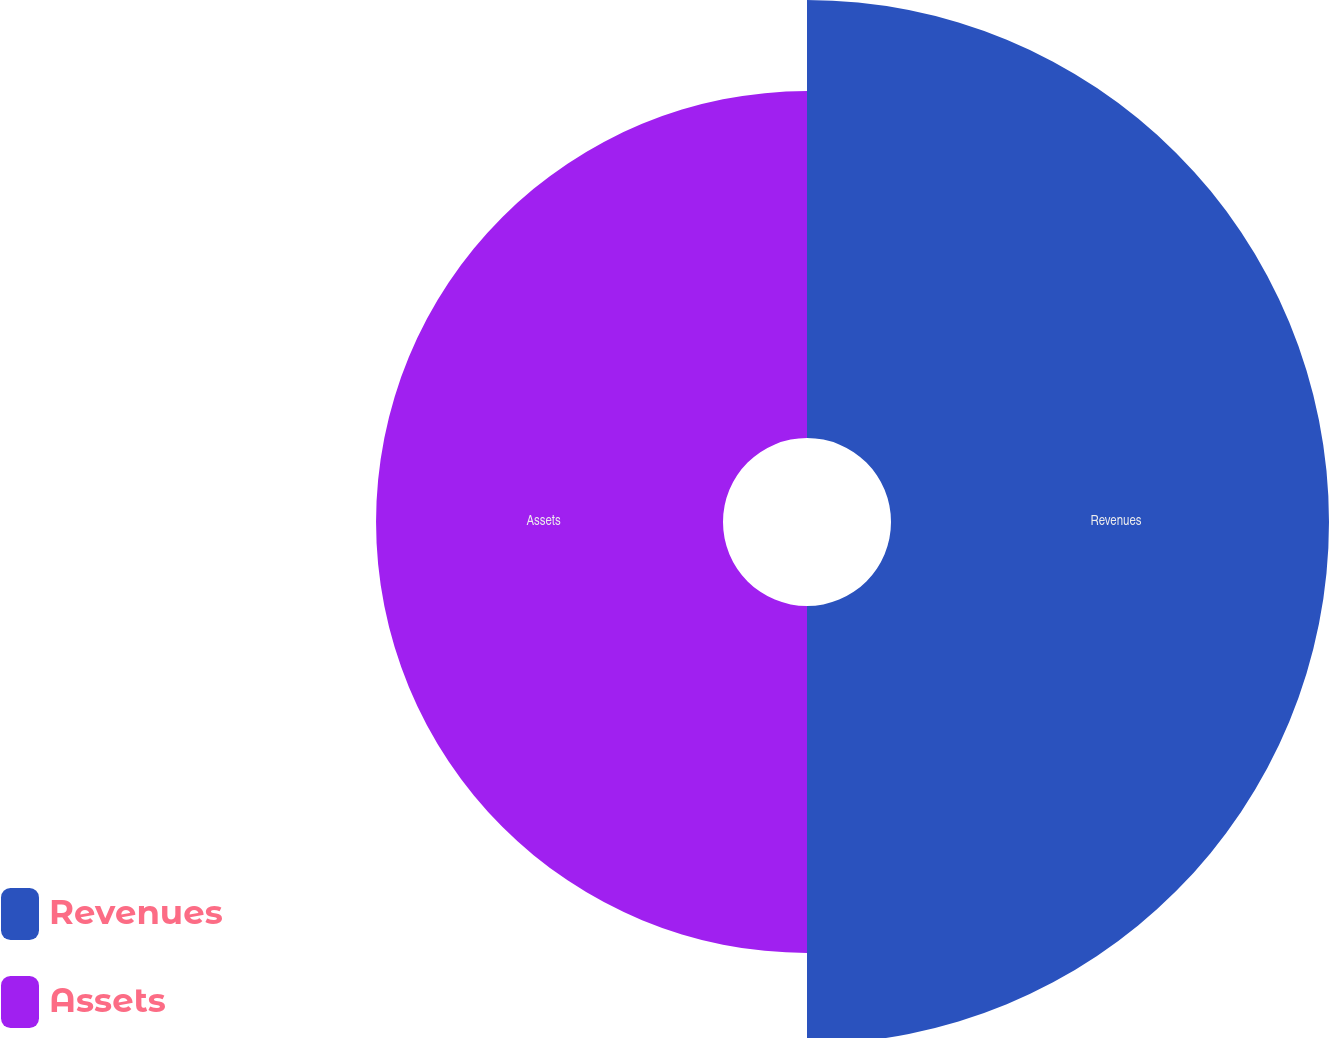<chart> <loc_0><loc_0><loc_500><loc_500><pie_chart><fcel>Revenues<fcel>Assets<nl><fcel>55.8%<fcel>44.2%<nl></chart> 